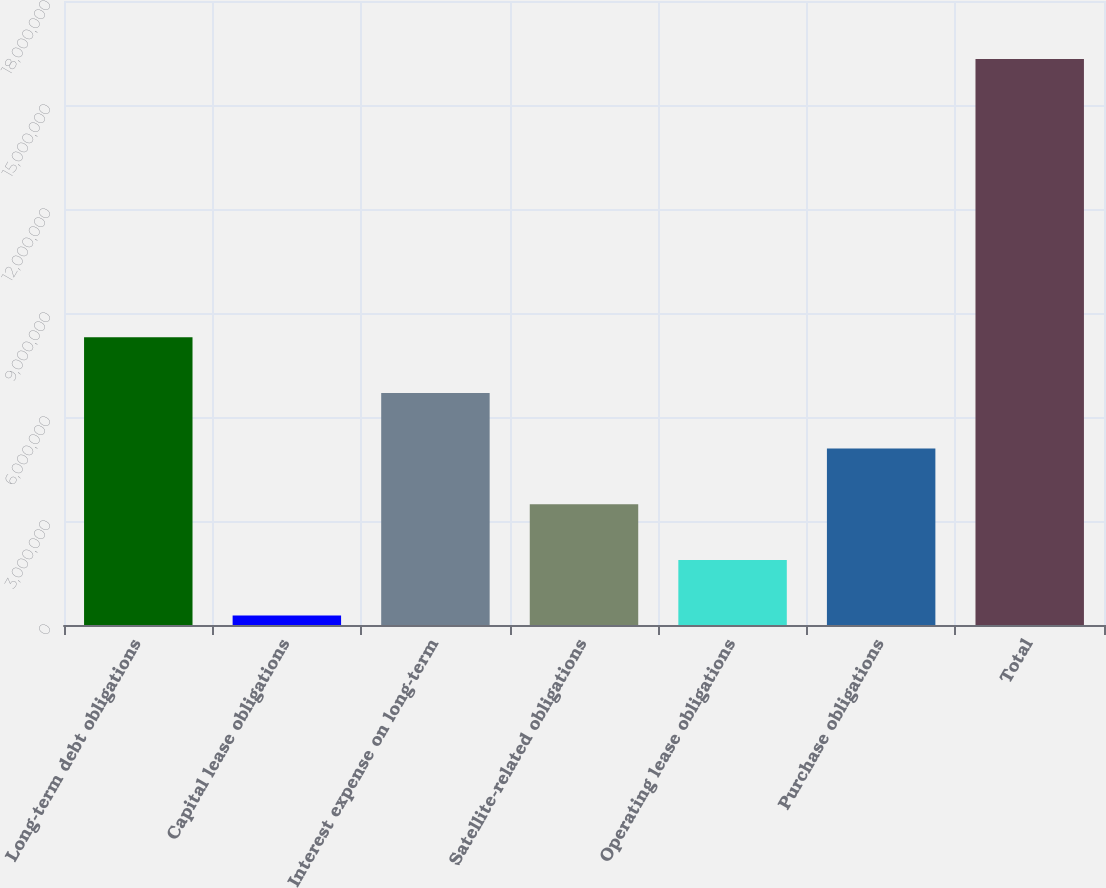<chart> <loc_0><loc_0><loc_500><loc_500><bar_chart><fcel>Long-term debt obligations<fcel>Capital lease obligations<fcel>Interest expense on long-term<fcel>Satellite-related obligations<fcel>Operating lease obligations<fcel>Purchase obligations<fcel>Total<nl><fcel>8.29867e+06<fcel>271908<fcel>6.69332e+06<fcel>3.48261e+06<fcel>1.87726e+06<fcel>5.08797e+06<fcel>1.63254e+07<nl></chart> 